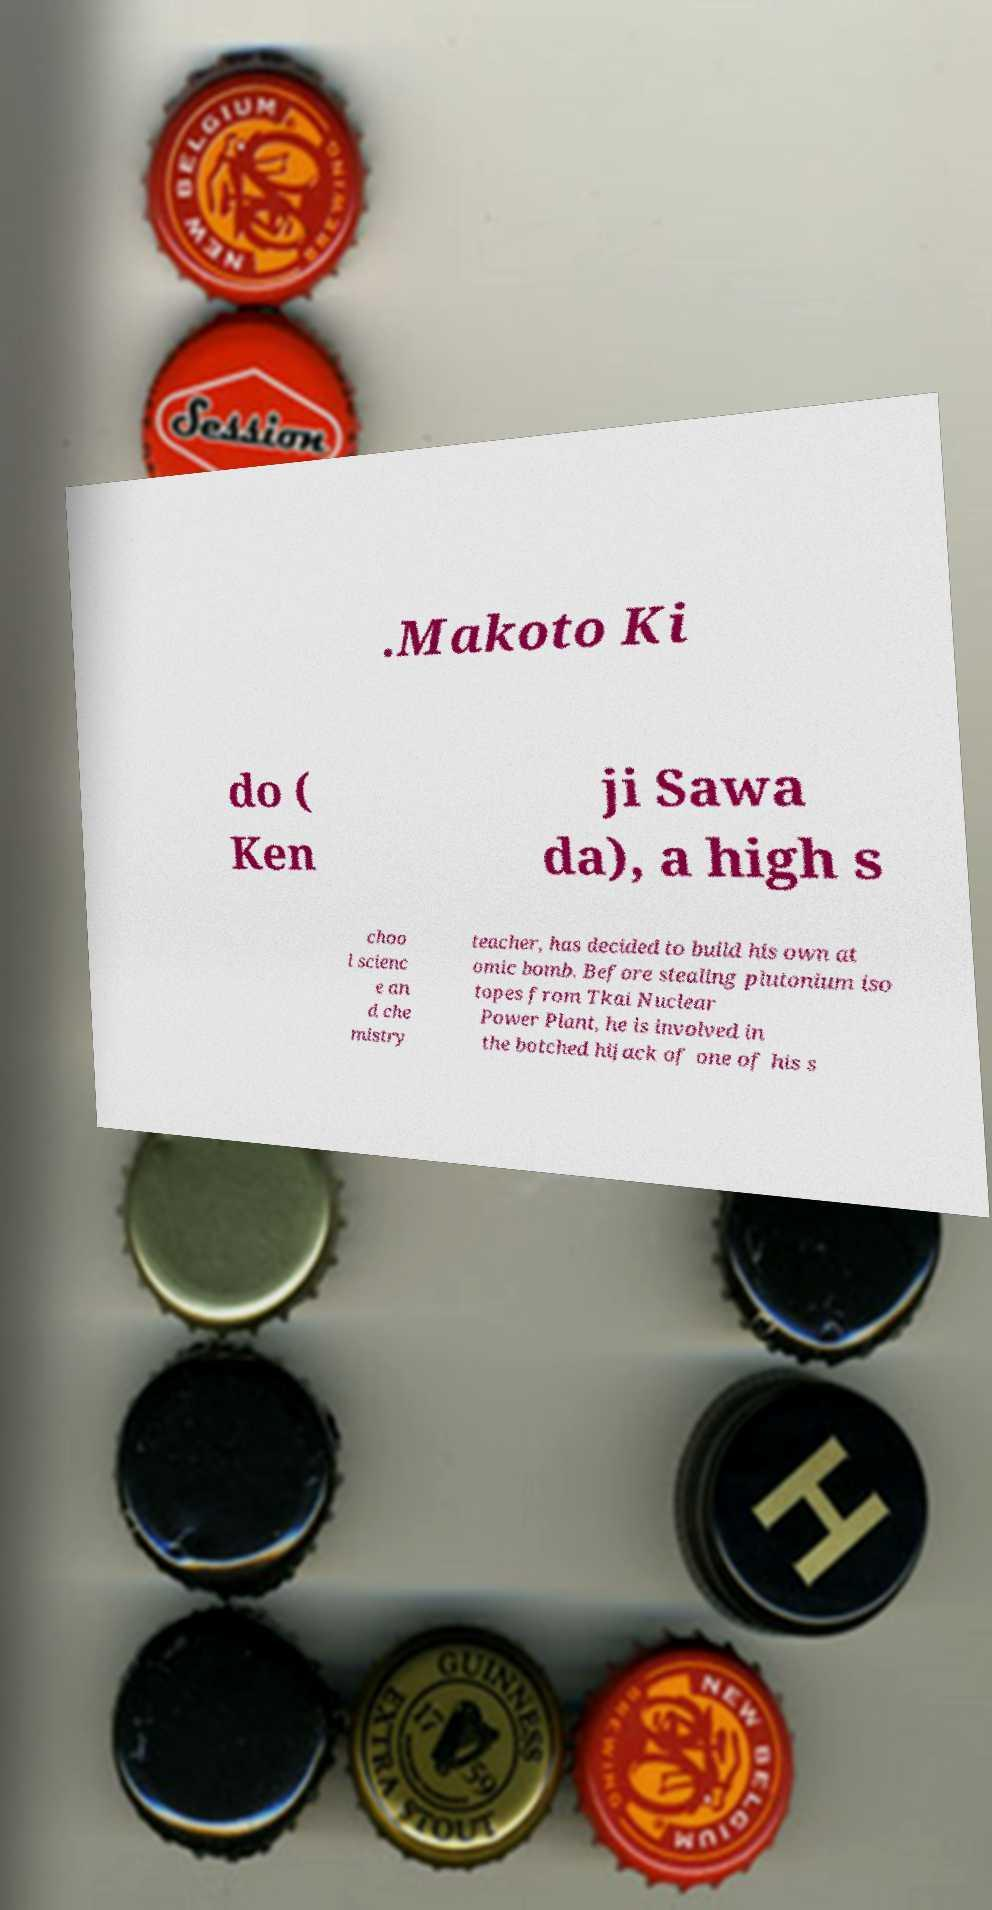Please read and relay the text visible in this image. What does it say? .Makoto Ki do ( Ken ji Sawa da), a high s choo l scienc e an d che mistry teacher, has decided to build his own at omic bomb. Before stealing plutonium iso topes from Tkai Nuclear Power Plant, he is involved in the botched hijack of one of his s 